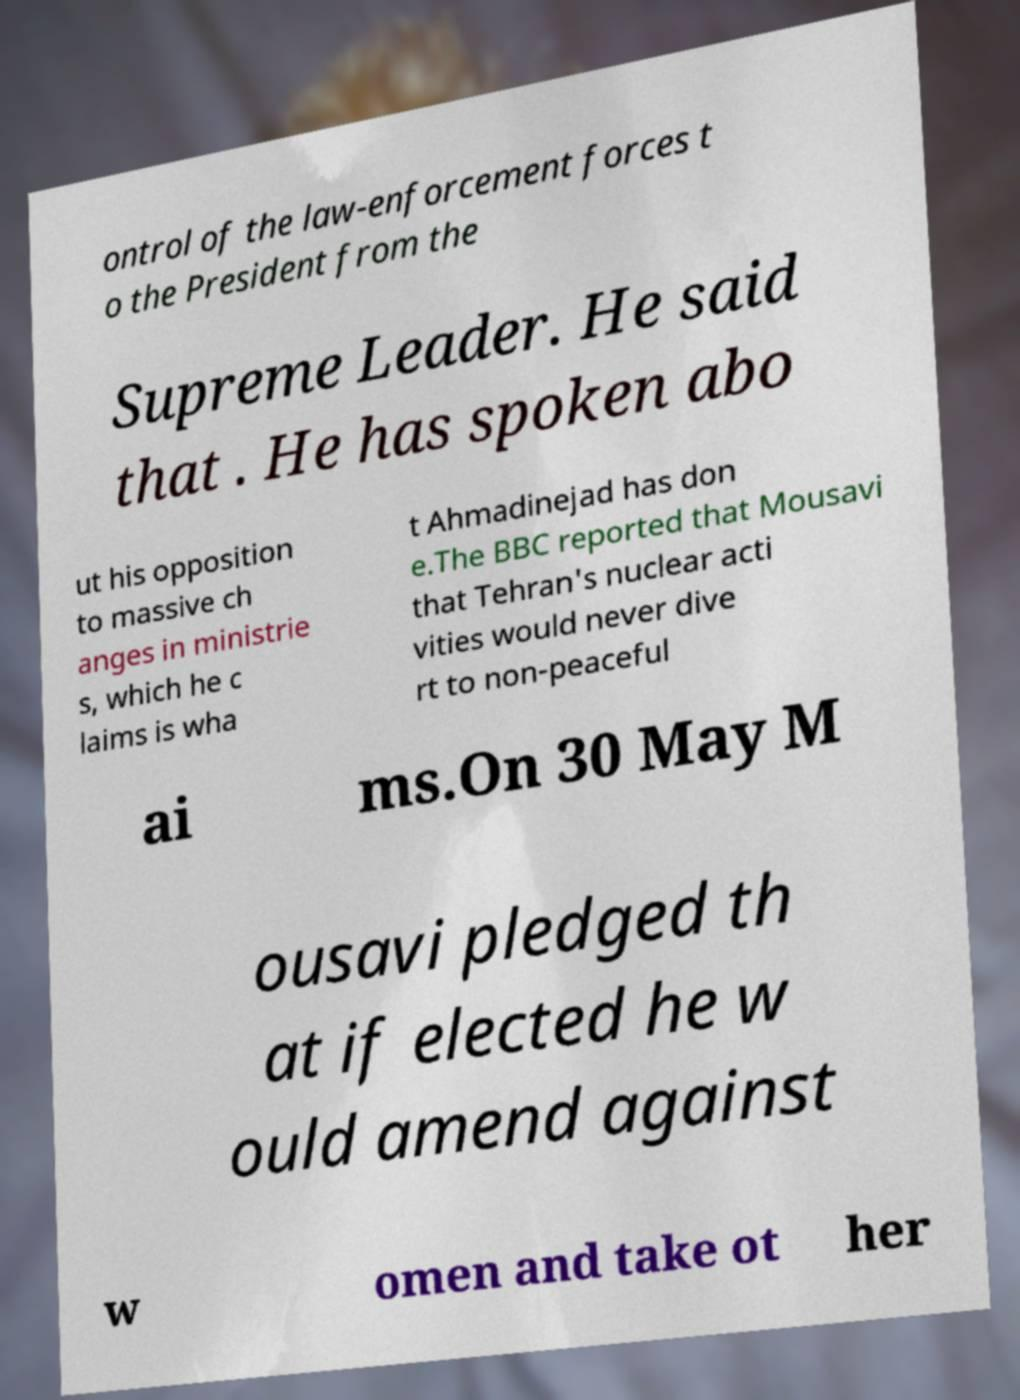Please read and relay the text visible in this image. What does it say? ontrol of the law-enforcement forces t o the President from the Supreme Leader. He said that . He has spoken abo ut his opposition to massive ch anges in ministrie s, which he c laims is wha t Ahmadinejad has don e.The BBC reported that Mousavi that Tehran's nuclear acti vities would never dive rt to non-peaceful ai ms.On 30 May M ousavi pledged th at if elected he w ould amend against w omen and take ot her 